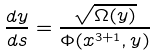<formula> <loc_0><loc_0><loc_500><loc_500>\frac { d y } { d s } = \frac { \sqrt { \Omega ( y ) } } { \Phi ( x ^ { 3 + 1 } , y ) }</formula> 